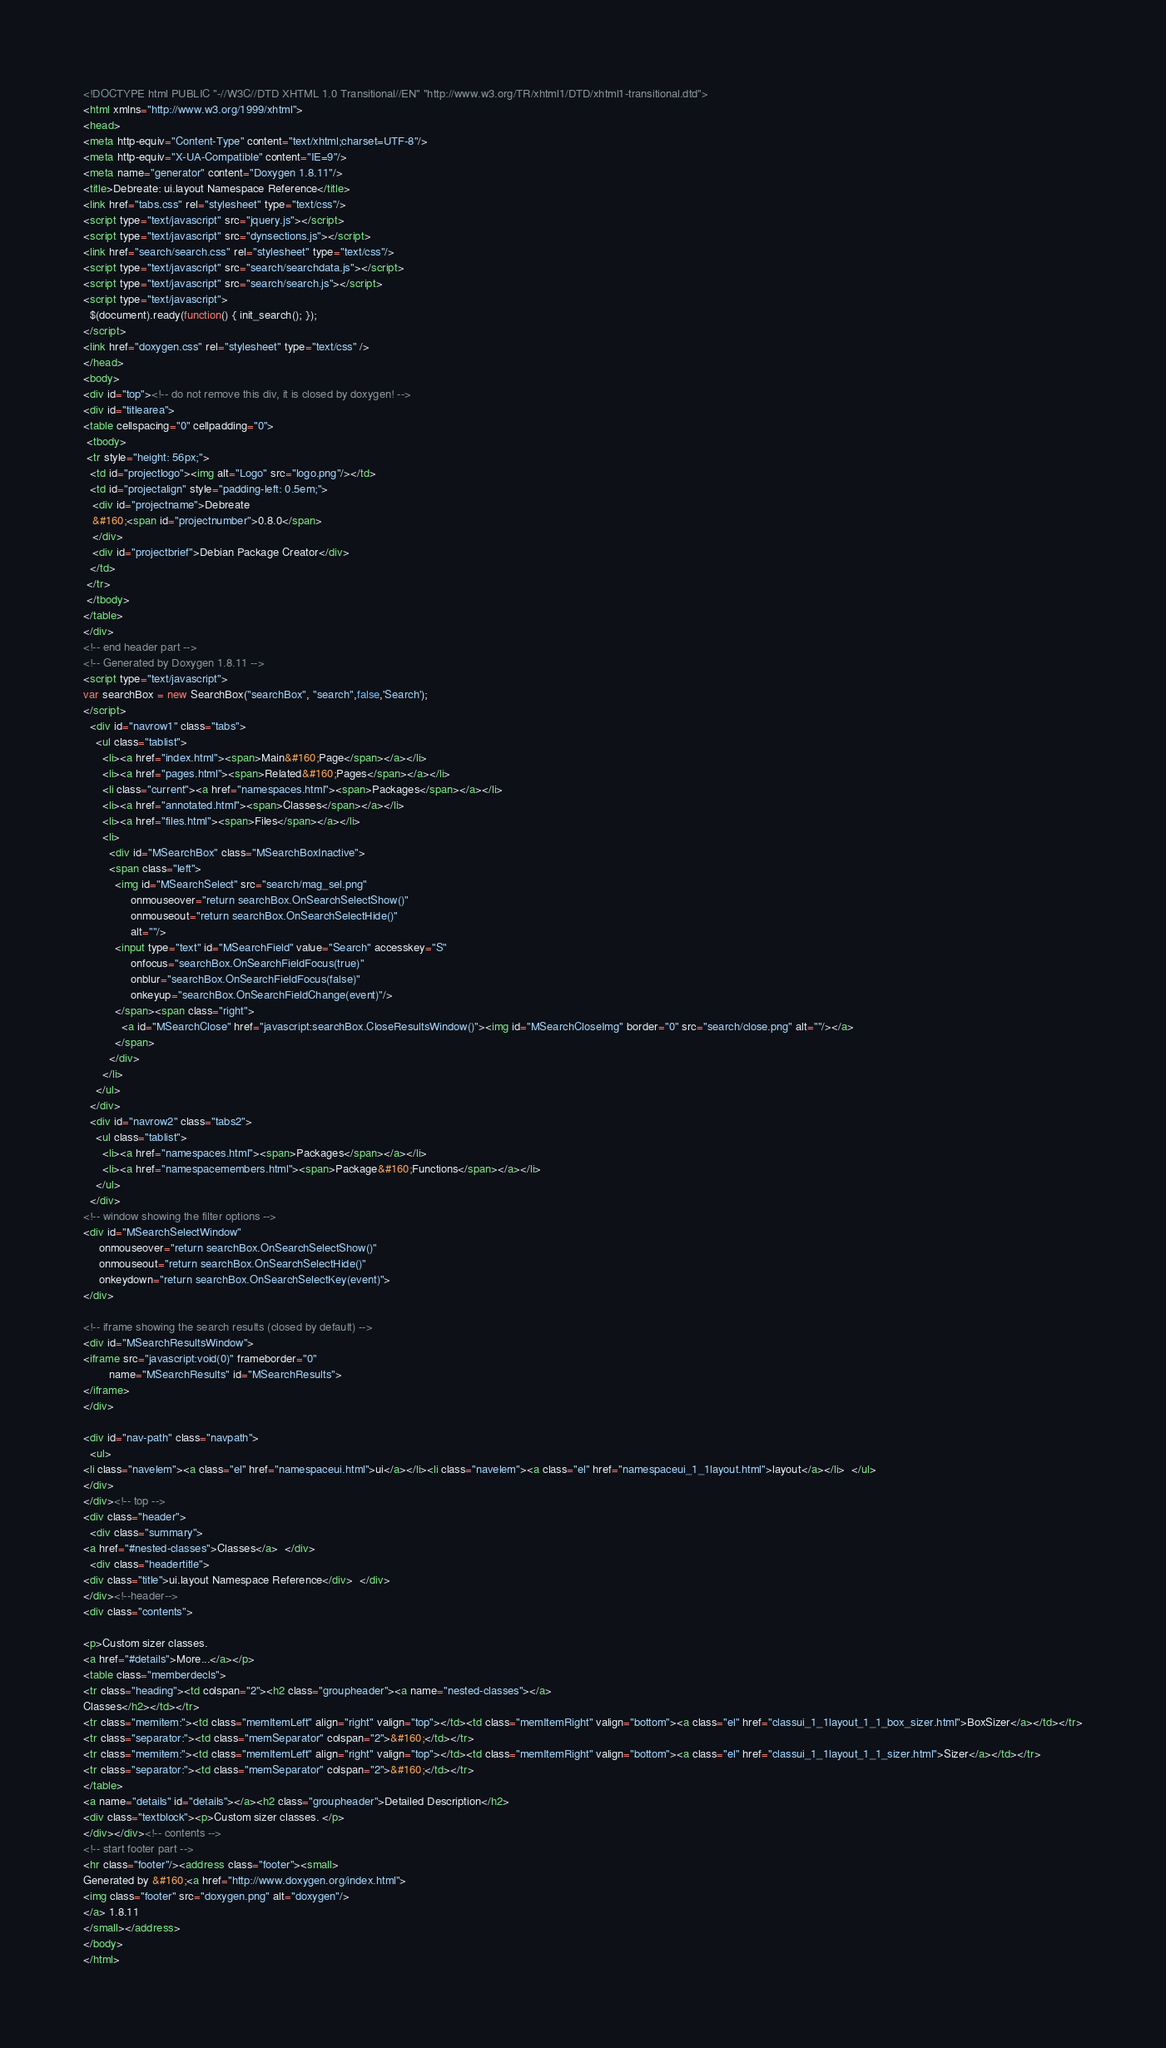<code> <loc_0><loc_0><loc_500><loc_500><_HTML_><!DOCTYPE html PUBLIC "-//W3C//DTD XHTML 1.0 Transitional//EN" "http://www.w3.org/TR/xhtml1/DTD/xhtml1-transitional.dtd">
<html xmlns="http://www.w3.org/1999/xhtml">
<head>
<meta http-equiv="Content-Type" content="text/xhtml;charset=UTF-8"/>
<meta http-equiv="X-UA-Compatible" content="IE=9"/>
<meta name="generator" content="Doxygen 1.8.11"/>
<title>Debreate: ui.layout Namespace Reference</title>
<link href="tabs.css" rel="stylesheet" type="text/css"/>
<script type="text/javascript" src="jquery.js"></script>
<script type="text/javascript" src="dynsections.js"></script>
<link href="search/search.css" rel="stylesheet" type="text/css"/>
<script type="text/javascript" src="search/searchdata.js"></script>
<script type="text/javascript" src="search/search.js"></script>
<script type="text/javascript">
  $(document).ready(function() { init_search(); });
</script>
<link href="doxygen.css" rel="stylesheet" type="text/css" />
</head>
<body>
<div id="top"><!-- do not remove this div, it is closed by doxygen! -->
<div id="titlearea">
<table cellspacing="0" cellpadding="0">
 <tbody>
 <tr style="height: 56px;">
  <td id="projectlogo"><img alt="Logo" src="logo.png"/></td>
  <td id="projectalign" style="padding-left: 0.5em;">
   <div id="projectname">Debreate
   &#160;<span id="projectnumber">0.8.0</span>
   </div>
   <div id="projectbrief">Debian Package Creator</div>
  </td>
 </tr>
 </tbody>
</table>
</div>
<!-- end header part -->
<!-- Generated by Doxygen 1.8.11 -->
<script type="text/javascript">
var searchBox = new SearchBox("searchBox", "search",false,'Search');
</script>
  <div id="navrow1" class="tabs">
    <ul class="tablist">
      <li><a href="index.html"><span>Main&#160;Page</span></a></li>
      <li><a href="pages.html"><span>Related&#160;Pages</span></a></li>
      <li class="current"><a href="namespaces.html"><span>Packages</span></a></li>
      <li><a href="annotated.html"><span>Classes</span></a></li>
      <li><a href="files.html"><span>Files</span></a></li>
      <li>
        <div id="MSearchBox" class="MSearchBoxInactive">
        <span class="left">
          <img id="MSearchSelect" src="search/mag_sel.png"
               onmouseover="return searchBox.OnSearchSelectShow()"
               onmouseout="return searchBox.OnSearchSelectHide()"
               alt=""/>
          <input type="text" id="MSearchField" value="Search" accesskey="S"
               onfocus="searchBox.OnSearchFieldFocus(true)" 
               onblur="searchBox.OnSearchFieldFocus(false)" 
               onkeyup="searchBox.OnSearchFieldChange(event)"/>
          </span><span class="right">
            <a id="MSearchClose" href="javascript:searchBox.CloseResultsWindow()"><img id="MSearchCloseImg" border="0" src="search/close.png" alt=""/></a>
          </span>
        </div>
      </li>
    </ul>
  </div>
  <div id="navrow2" class="tabs2">
    <ul class="tablist">
      <li><a href="namespaces.html"><span>Packages</span></a></li>
      <li><a href="namespacemembers.html"><span>Package&#160;Functions</span></a></li>
    </ul>
  </div>
<!-- window showing the filter options -->
<div id="MSearchSelectWindow"
     onmouseover="return searchBox.OnSearchSelectShow()"
     onmouseout="return searchBox.OnSearchSelectHide()"
     onkeydown="return searchBox.OnSearchSelectKey(event)">
</div>

<!-- iframe showing the search results (closed by default) -->
<div id="MSearchResultsWindow">
<iframe src="javascript:void(0)" frameborder="0" 
        name="MSearchResults" id="MSearchResults">
</iframe>
</div>

<div id="nav-path" class="navpath">
  <ul>
<li class="navelem"><a class="el" href="namespaceui.html">ui</a></li><li class="navelem"><a class="el" href="namespaceui_1_1layout.html">layout</a></li>  </ul>
</div>
</div><!-- top -->
<div class="header">
  <div class="summary">
<a href="#nested-classes">Classes</a>  </div>
  <div class="headertitle">
<div class="title">ui.layout Namespace Reference</div>  </div>
</div><!--header-->
<div class="contents">

<p>Custom sizer classes.  
<a href="#details">More...</a></p>
<table class="memberdecls">
<tr class="heading"><td colspan="2"><h2 class="groupheader"><a name="nested-classes"></a>
Classes</h2></td></tr>
<tr class="memitem:"><td class="memItemLeft" align="right" valign="top"></td><td class="memItemRight" valign="bottom"><a class="el" href="classui_1_1layout_1_1_box_sizer.html">BoxSizer</a></td></tr>
<tr class="separator:"><td class="memSeparator" colspan="2">&#160;</td></tr>
<tr class="memitem:"><td class="memItemLeft" align="right" valign="top"></td><td class="memItemRight" valign="bottom"><a class="el" href="classui_1_1layout_1_1_sizer.html">Sizer</a></td></tr>
<tr class="separator:"><td class="memSeparator" colspan="2">&#160;</td></tr>
</table>
<a name="details" id="details"></a><h2 class="groupheader">Detailed Description</h2>
<div class="textblock"><p>Custom sizer classes. </p>
</div></div><!-- contents -->
<!-- start footer part -->
<hr class="footer"/><address class="footer"><small>
Generated by &#160;<a href="http://www.doxygen.org/index.html">
<img class="footer" src="doxygen.png" alt="doxygen"/>
</a> 1.8.11
</small></address>
</body>
</html>
</code> 